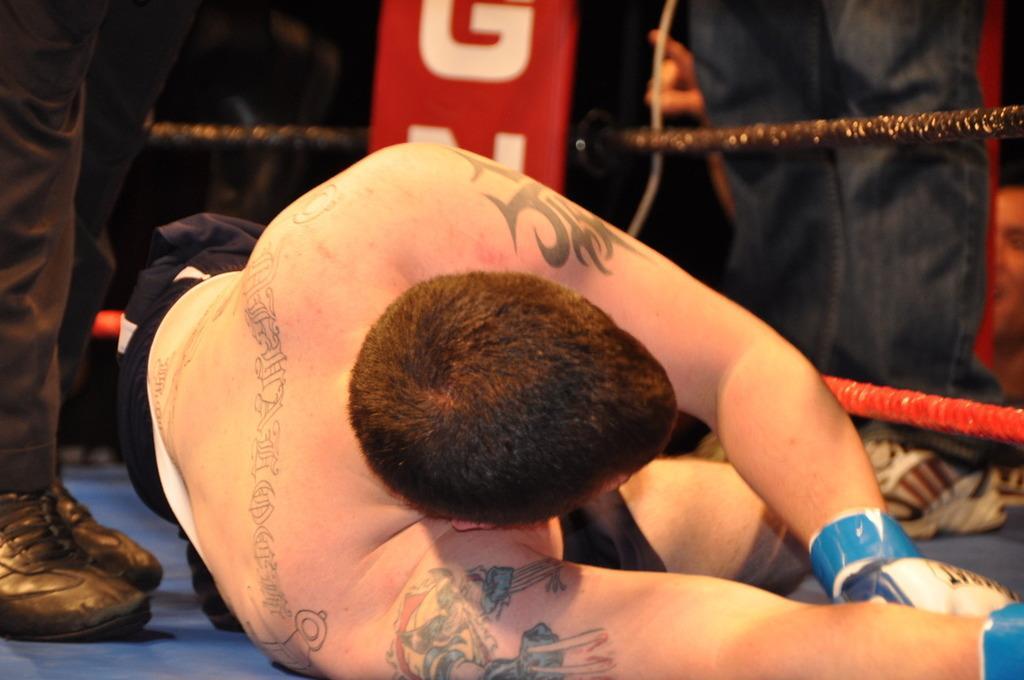How would you summarize this image in a sentence or two? In the center of the image there is a person laying on the ground. On the left side of the image we can see persons legs. On the right side of the image we can see persons legs and person. In the background we can see ropes. 